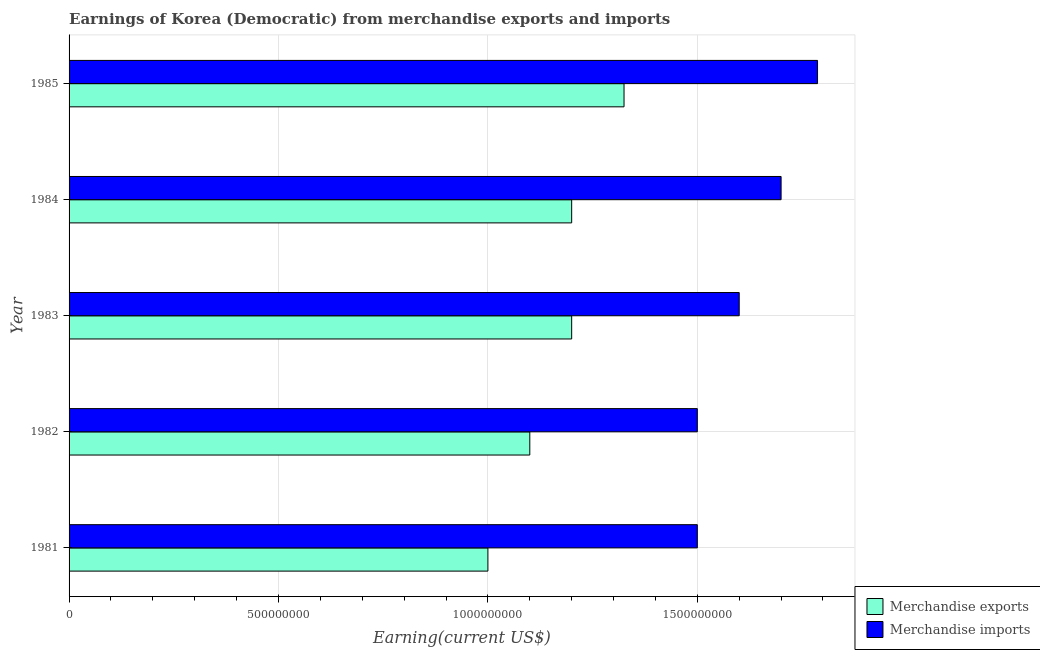How many different coloured bars are there?
Your answer should be very brief. 2. How many groups of bars are there?
Your answer should be very brief. 5. Are the number of bars per tick equal to the number of legend labels?
Ensure brevity in your answer.  Yes. How many bars are there on the 3rd tick from the top?
Provide a succinct answer. 2. How many bars are there on the 3rd tick from the bottom?
Make the answer very short. 2. What is the earnings from merchandise imports in 1984?
Ensure brevity in your answer.  1.70e+09. Across all years, what is the maximum earnings from merchandise imports?
Your answer should be compact. 1.79e+09. Across all years, what is the minimum earnings from merchandise imports?
Make the answer very short. 1.50e+09. In which year was the earnings from merchandise imports maximum?
Offer a terse response. 1985. What is the total earnings from merchandise exports in the graph?
Give a very brief answer. 5.82e+09. What is the difference between the earnings from merchandise exports in 1982 and that in 1985?
Your response must be concise. -2.25e+08. What is the difference between the earnings from merchandise exports in 1985 and the earnings from merchandise imports in 1982?
Your answer should be compact. -1.75e+08. What is the average earnings from merchandise exports per year?
Keep it short and to the point. 1.16e+09. In the year 1984, what is the difference between the earnings from merchandise imports and earnings from merchandise exports?
Your answer should be compact. 5.00e+08. What is the ratio of the earnings from merchandise exports in 1981 to that in 1985?
Your response must be concise. 0.76. Is the earnings from merchandise imports in 1981 less than that in 1984?
Ensure brevity in your answer.  Yes. Is the difference between the earnings from merchandise exports in 1983 and 1985 greater than the difference between the earnings from merchandise imports in 1983 and 1985?
Your response must be concise. Yes. What is the difference between the highest and the second highest earnings from merchandise exports?
Your answer should be very brief. 1.25e+08. What is the difference between the highest and the lowest earnings from merchandise exports?
Make the answer very short. 3.25e+08. In how many years, is the earnings from merchandise exports greater than the average earnings from merchandise exports taken over all years?
Provide a short and direct response. 3. Is the sum of the earnings from merchandise exports in 1981 and 1985 greater than the maximum earnings from merchandise imports across all years?
Provide a succinct answer. Yes. What does the 1st bar from the top in 1985 represents?
Your response must be concise. Merchandise imports. What does the 1st bar from the bottom in 1981 represents?
Your answer should be compact. Merchandise exports. Are all the bars in the graph horizontal?
Ensure brevity in your answer.  Yes. What is the difference between two consecutive major ticks on the X-axis?
Your answer should be compact. 5.00e+08. Are the values on the major ticks of X-axis written in scientific E-notation?
Provide a succinct answer. No. Where does the legend appear in the graph?
Your answer should be compact. Bottom right. How are the legend labels stacked?
Offer a terse response. Vertical. What is the title of the graph?
Provide a succinct answer. Earnings of Korea (Democratic) from merchandise exports and imports. What is the label or title of the X-axis?
Your response must be concise. Earning(current US$). What is the label or title of the Y-axis?
Provide a short and direct response. Year. What is the Earning(current US$) in Merchandise exports in 1981?
Ensure brevity in your answer.  1.00e+09. What is the Earning(current US$) in Merchandise imports in 1981?
Offer a terse response. 1.50e+09. What is the Earning(current US$) of Merchandise exports in 1982?
Keep it short and to the point. 1.10e+09. What is the Earning(current US$) in Merchandise imports in 1982?
Provide a succinct answer. 1.50e+09. What is the Earning(current US$) of Merchandise exports in 1983?
Offer a terse response. 1.20e+09. What is the Earning(current US$) in Merchandise imports in 1983?
Ensure brevity in your answer.  1.60e+09. What is the Earning(current US$) of Merchandise exports in 1984?
Give a very brief answer. 1.20e+09. What is the Earning(current US$) of Merchandise imports in 1984?
Provide a short and direct response. 1.70e+09. What is the Earning(current US$) in Merchandise exports in 1985?
Offer a terse response. 1.32e+09. What is the Earning(current US$) of Merchandise imports in 1985?
Provide a succinct answer. 1.79e+09. Across all years, what is the maximum Earning(current US$) of Merchandise exports?
Offer a terse response. 1.32e+09. Across all years, what is the maximum Earning(current US$) of Merchandise imports?
Your answer should be very brief. 1.79e+09. Across all years, what is the minimum Earning(current US$) in Merchandise exports?
Offer a terse response. 1.00e+09. Across all years, what is the minimum Earning(current US$) of Merchandise imports?
Provide a short and direct response. 1.50e+09. What is the total Earning(current US$) of Merchandise exports in the graph?
Offer a very short reply. 5.82e+09. What is the total Earning(current US$) of Merchandise imports in the graph?
Your answer should be compact. 8.09e+09. What is the difference between the Earning(current US$) in Merchandise exports in 1981 and that in 1982?
Make the answer very short. -1.00e+08. What is the difference between the Earning(current US$) in Merchandise imports in 1981 and that in 1982?
Keep it short and to the point. 0. What is the difference between the Earning(current US$) in Merchandise exports in 1981 and that in 1983?
Make the answer very short. -2.00e+08. What is the difference between the Earning(current US$) of Merchandise imports in 1981 and that in 1983?
Your response must be concise. -1.00e+08. What is the difference between the Earning(current US$) in Merchandise exports in 1981 and that in 1984?
Keep it short and to the point. -2.00e+08. What is the difference between the Earning(current US$) of Merchandise imports in 1981 and that in 1984?
Keep it short and to the point. -2.00e+08. What is the difference between the Earning(current US$) of Merchandise exports in 1981 and that in 1985?
Provide a short and direct response. -3.25e+08. What is the difference between the Earning(current US$) in Merchandise imports in 1981 and that in 1985?
Offer a very short reply. -2.87e+08. What is the difference between the Earning(current US$) of Merchandise exports in 1982 and that in 1983?
Your response must be concise. -1.00e+08. What is the difference between the Earning(current US$) in Merchandise imports in 1982 and that in 1983?
Offer a very short reply. -1.00e+08. What is the difference between the Earning(current US$) of Merchandise exports in 1982 and that in 1984?
Your response must be concise. -1.00e+08. What is the difference between the Earning(current US$) of Merchandise imports in 1982 and that in 1984?
Keep it short and to the point. -2.00e+08. What is the difference between the Earning(current US$) of Merchandise exports in 1982 and that in 1985?
Keep it short and to the point. -2.25e+08. What is the difference between the Earning(current US$) in Merchandise imports in 1982 and that in 1985?
Your answer should be very brief. -2.87e+08. What is the difference between the Earning(current US$) of Merchandise exports in 1983 and that in 1984?
Offer a terse response. 0. What is the difference between the Earning(current US$) in Merchandise imports in 1983 and that in 1984?
Your answer should be very brief. -1.00e+08. What is the difference between the Earning(current US$) of Merchandise exports in 1983 and that in 1985?
Your answer should be very brief. -1.25e+08. What is the difference between the Earning(current US$) in Merchandise imports in 1983 and that in 1985?
Your answer should be very brief. -1.87e+08. What is the difference between the Earning(current US$) of Merchandise exports in 1984 and that in 1985?
Keep it short and to the point. -1.25e+08. What is the difference between the Earning(current US$) in Merchandise imports in 1984 and that in 1985?
Your response must be concise. -8.70e+07. What is the difference between the Earning(current US$) of Merchandise exports in 1981 and the Earning(current US$) of Merchandise imports in 1982?
Your answer should be compact. -5.00e+08. What is the difference between the Earning(current US$) of Merchandise exports in 1981 and the Earning(current US$) of Merchandise imports in 1983?
Provide a short and direct response. -6.00e+08. What is the difference between the Earning(current US$) of Merchandise exports in 1981 and the Earning(current US$) of Merchandise imports in 1984?
Your response must be concise. -7.00e+08. What is the difference between the Earning(current US$) in Merchandise exports in 1981 and the Earning(current US$) in Merchandise imports in 1985?
Your answer should be compact. -7.87e+08. What is the difference between the Earning(current US$) of Merchandise exports in 1982 and the Earning(current US$) of Merchandise imports in 1983?
Keep it short and to the point. -5.00e+08. What is the difference between the Earning(current US$) of Merchandise exports in 1982 and the Earning(current US$) of Merchandise imports in 1984?
Give a very brief answer. -6.00e+08. What is the difference between the Earning(current US$) of Merchandise exports in 1982 and the Earning(current US$) of Merchandise imports in 1985?
Your answer should be very brief. -6.87e+08. What is the difference between the Earning(current US$) of Merchandise exports in 1983 and the Earning(current US$) of Merchandise imports in 1984?
Your response must be concise. -5.00e+08. What is the difference between the Earning(current US$) in Merchandise exports in 1983 and the Earning(current US$) in Merchandise imports in 1985?
Offer a terse response. -5.87e+08. What is the difference between the Earning(current US$) of Merchandise exports in 1984 and the Earning(current US$) of Merchandise imports in 1985?
Keep it short and to the point. -5.87e+08. What is the average Earning(current US$) in Merchandise exports per year?
Your answer should be very brief. 1.16e+09. What is the average Earning(current US$) of Merchandise imports per year?
Your answer should be very brief. 1.62e+09. In the year 1981, what is the difference between the Earning(current US$) in Merchandise exports and Earning(current US$) in Merchandise imports?
Give a very brief answer. -5.00e+08. In the year 1982, what is the difference between the Earning(current US$) of Merchandise exports and Earning(current US$) of Merchandise imports?
Ensure brevity in your answer.  -4.00e+08. In the year 1983, what is the difference between the Earning(current US$) of Merchandise exports and Earning(current US$) of Merchandise imports?
Offer a terse response. -4.00e+08. In the year 1984, what is the difference between the Earning(current US$) in Merchandise exports and Earning(current US$) in Merchandise imports?
Provide a succinct answer. -5.00e+08. In the year 1985, what is the difference between the Earning(current US$) of Merchandise exports and Earning(current US$) of Merchandise imports?
Offer a terse response. -4.62e+08. What is the ratio of the Earning(current US$) of Merchandise imports in 1981 to that in 1982?
Offer a terse response. 1. What is the ratio of the Earning(current US$) of Merchandise imports in 1981 to that in 1983?
Give a very brief answer. 0.94. What is the ratio of the Earning(current US$) of Merchandise imports in 1981 to that in 1984?
Your answer should be very brief. 0.88. What is the ratio of the Earning(current US$) in Merchandise exports in 1981 to that in 1985?
Keep it short and to the point. 0.75. What is the ratio of the Earning(current US$) in Merchandise imports in 1981 to that in 1985?
Your response must be concise. 0.84. What is the ratio of the Earning(current US$) of Merchandise imports in 1982 to that in 1983?
Offer a very short reply. 0.94. What is the ratio of the Earning(current US$) of Merchandise imports in 1982 to that in 1984?
Make the answer very short. 0.88. What is the ratio of the Earning(current US$) of Merchandise exports in 1982 to that in 1985?
Provide a short and direct response. 0.83. What is the ratio of the Earning(current US$) of Merchandise imports in 1982 to that in 1985?
Offer a very short reply. 0.84. What is the ratio of the Earning(current US$) in Merchandise exports in 1983 to that in 1984?
Provide a succinct answer. 1. What is the ratio of the Earning(current US$) in Merchandise imports in 1983 to that in 1984?
Keep it short and to the point. 0.94. What is the ratio of the Earning(current US$) in Merchandise exports in 1983 to that in 1985?
Provide a short and direct response. 0.91. What is the ratio of the Earning(current US$) of Merchandise imports in 1983 to that in 1985?
Your answer should be very brief. 0.9. What is the ratio of the Earning(current US$) of Merchandise exports in 1984 to that in 1985?
Keep it short and to the point. 0.91. What is the ratio of the Earning(current US$) in Merchandise imports in 1984 to that in 1985?
Provide a short and direct response. 0.95. What is the difference between the highest and the second highest Earning(current US$) in Merchandise exports?
Ensure brevity in your answer.  1.25e+08. What is the difference between the highest and the second highest Earning(current US$) in Merchandise imports?
Provide a short and direct response. 8.70e+07. What is the difference between the highest and the lowest Earning(current US$) in Merchandise exports?
Offer a terse response. 3.25e+08. What is the difference between the highest and the lowest Earning(current US$) of Merchandise imports?
Your response must be concise. 2.87e+08. 